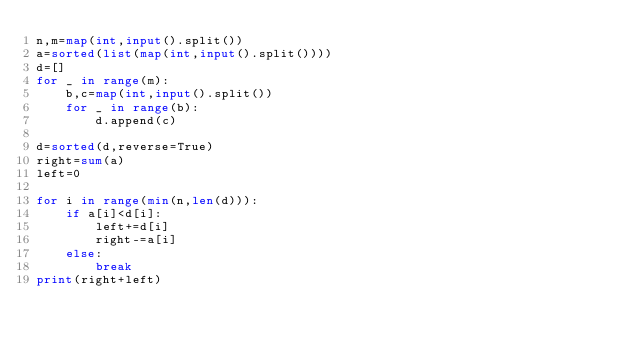Convert code to text. <code><loc_0><loc_0><loc_500><loc_500><_Python_>n,m=map(int,input().split())
a=sorted(list(map(int,input().split())))
d=[]
for _ in range(m):
    b,c=map(int,input().split())
    for _ in range(b):
    	d.append(c)

d=sorted(d,reverse=True)
right=sum(a)
left=0

for i in range(min(n,len(d))):
    if a[i]<d[i]:
        left+=d[i]
        right-=a[i]
    else:
        break
print(right+left)</code> 